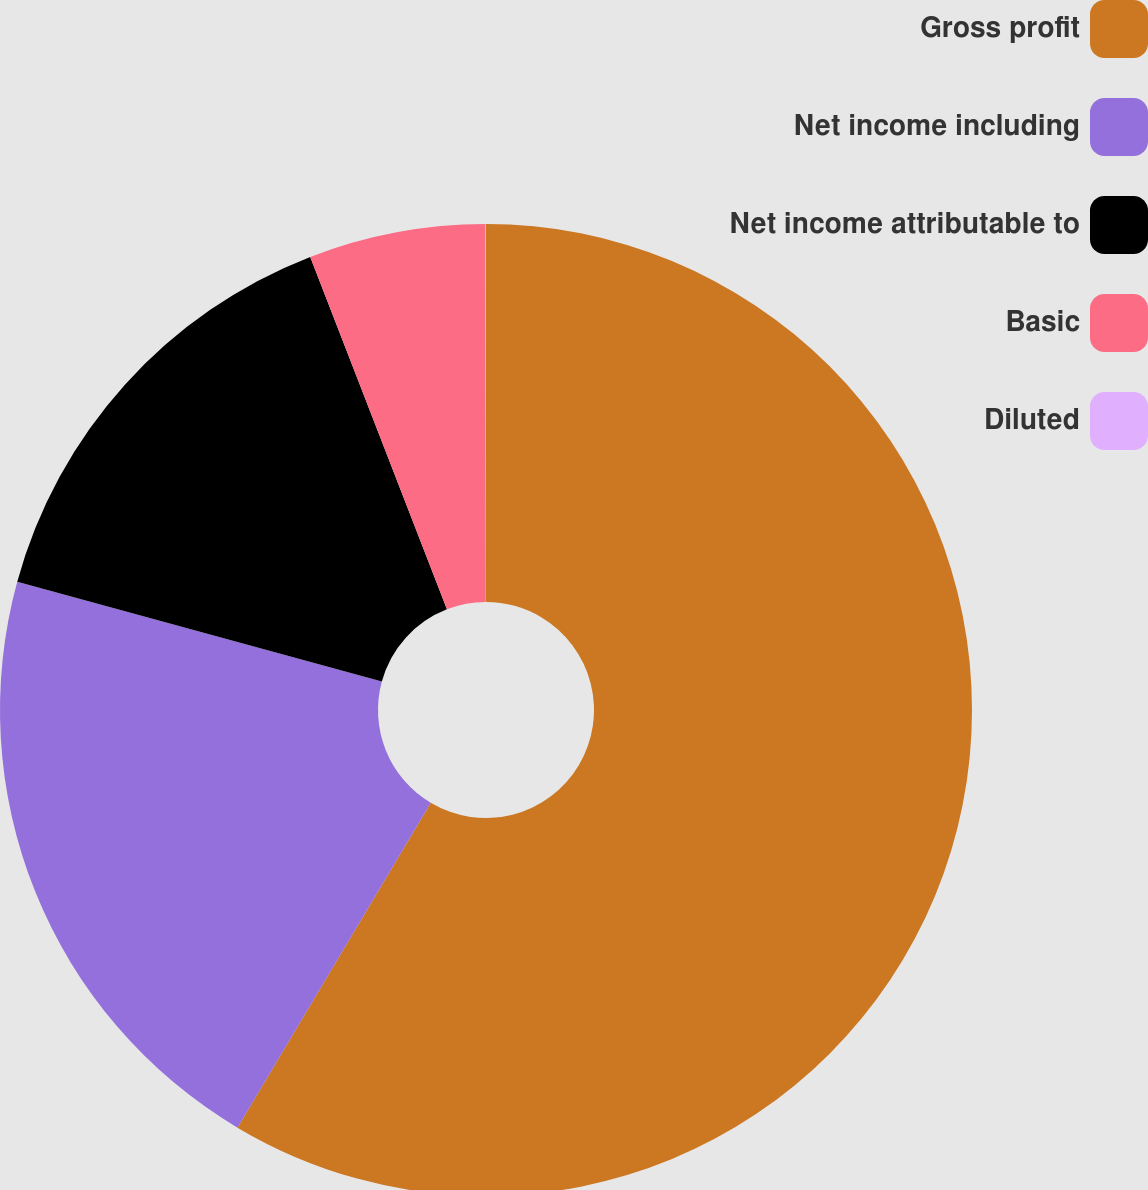Convert chart. <chart><loc_0><loc_0><loc_500><loc_500><pie_chart><fcel>Gross profit<fcel>Net income including<fcel>Net income attributable to<fcel>Basic<fcel>Diluted<nl><fcel>58.55%<fcel>20.71%<fcel>14.86%<fcel>5.87%<fcel>0.02%<nl></chart> 